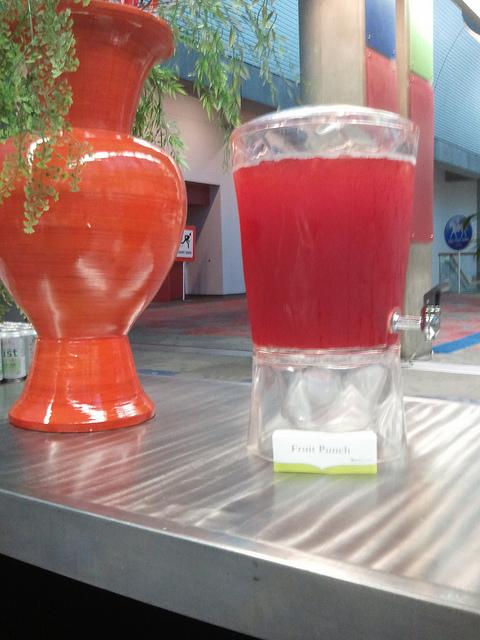What type of station is this?

Choices:
A) fire
B) bus
C) train
D) beverage beverage 